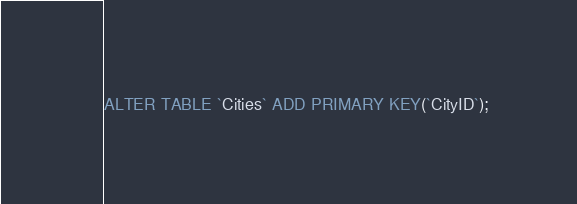Convert code to text. <code><loc_0><loc_0><loc_500><loc_500><_SQL_>ALTER TABLE `Cities` ADD PRIMARY KEY(`CityID`);
</code> 